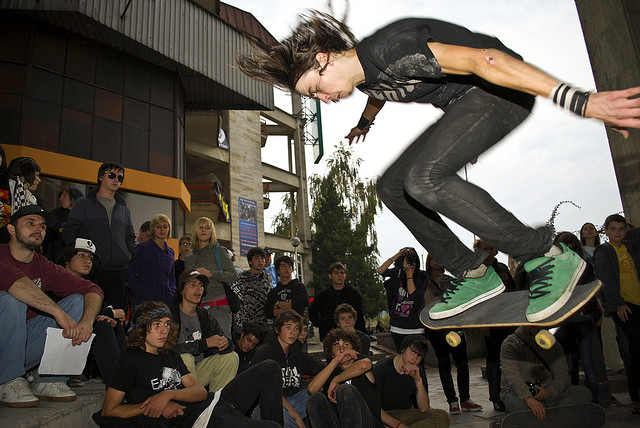<image>What shoe company is the sponsor of this skateboarding event? It is unknown which shoe company is the sponsor of this skateboarding event. It could be 'Vans', 'Walker', 'DC' or 'Nike'. What shoe company is the sponsor of this skateboarding event? I am not sure which shoe company is the sponsor of this skateboarding event. It can be either Vans, Walker, DC, or Nike. 